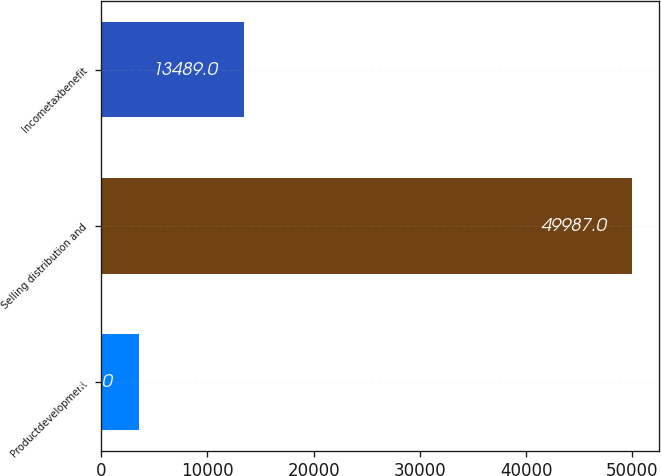<chart> <loc_0><loc_0><loc_500><loc_500><bar_chart><fcel>Productdevelopment<fcel>Selling distribution and<fcel>Incometaxbenefit<nl><fcel>3527<fcel>49987<fcel>13489<nl></chart> 